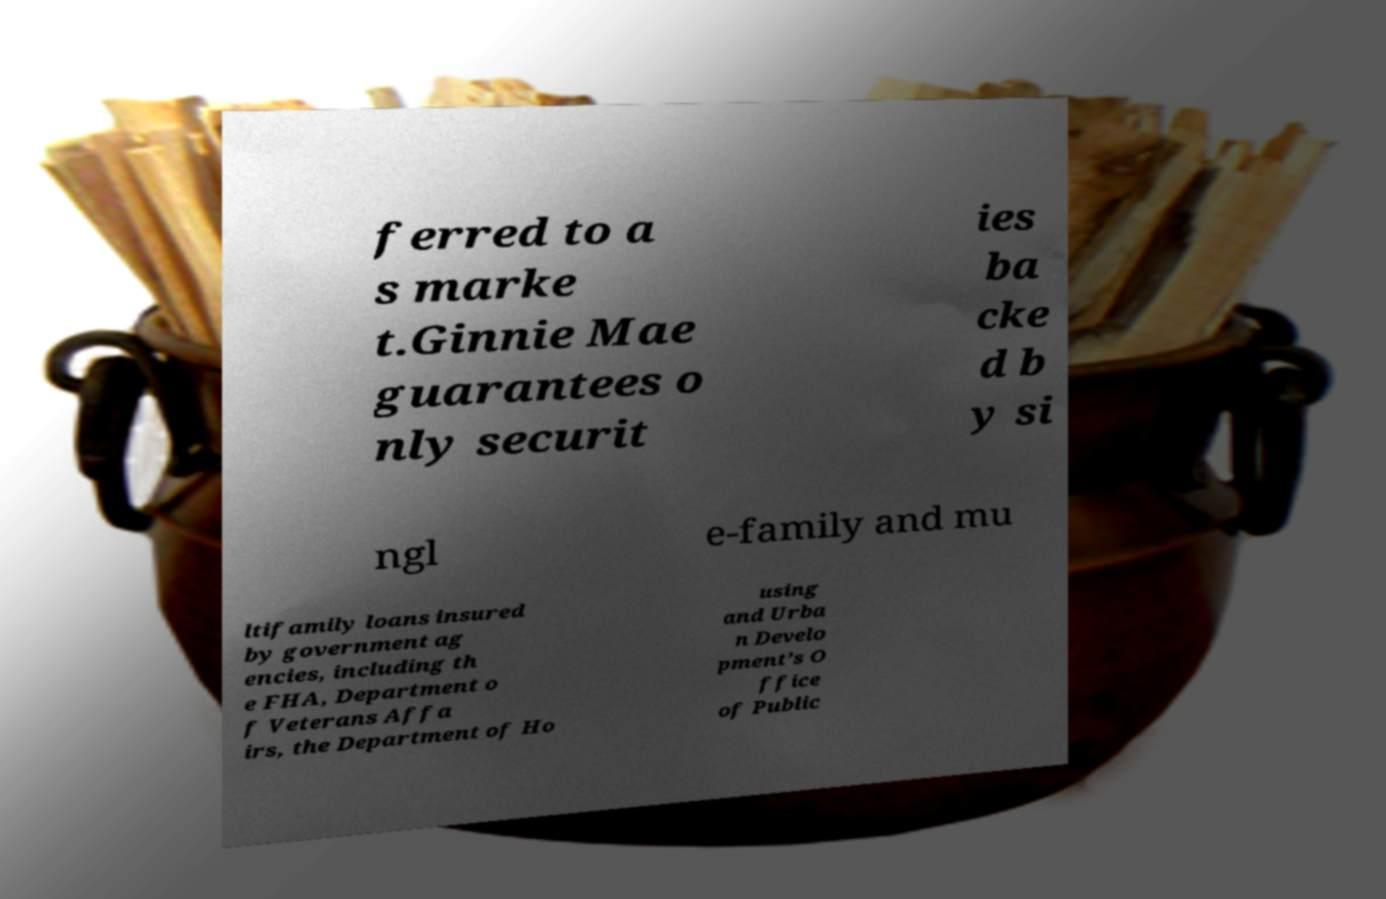Could you extract and type out the text from this image? ferred to a s marke t.Ginnie Mae guarantees o nly securit ies ba cke d b y si ngl e-family and mu ltifamily loans insured by government ag encies, including th e FHA, Department o f Veterans Affa irs, the Department of Ho using and Urba n Develo pment’s O ffice of Public 